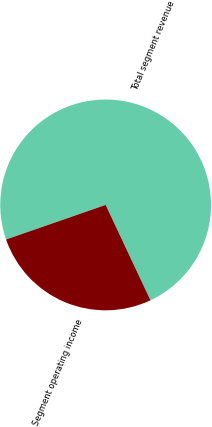Convert chart. <chart><loc_0><loc_0><loc_500><loc_500><pie_chart><fcel>Total segment revenue<fcel>Segment operating income<nl><fcel>73.33%<fcel>26.67%<nl></chart> 